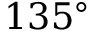<formula> <loc_0><loc_0><loc_500><loc_500>1 3 5 ^ { \circ }</formula> 